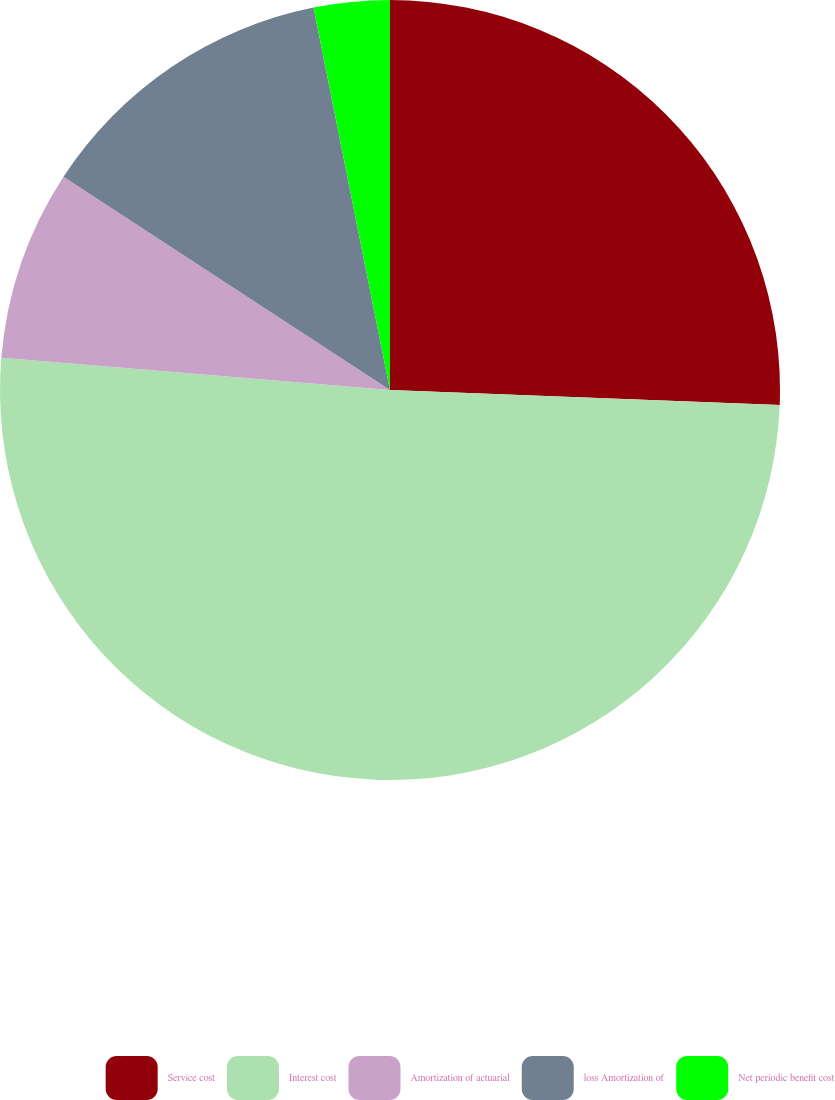<chart> <loc_0><loc_0><loc_500><loc_500><pie_chart><fcel>Service cost<fcel>Interest cost<fcel>Amortization of actuarial<fcel>loss Amortization of<fcel>Net periodic benefit cost<nl><fcel>25.61%<fcel>50.71%<fcel>7.89%<fcel>12.65%<fcel>3.14%<nl></chart> 